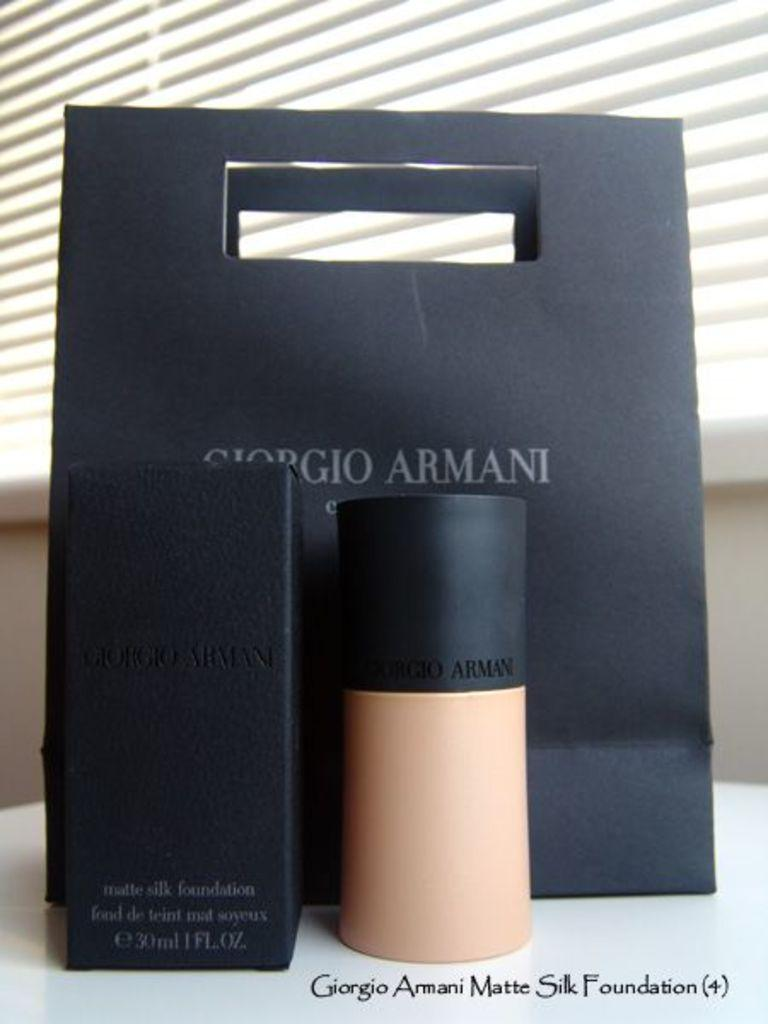Provide a one-sentence caption for the provided image. A black Giorgio Armani bag with a flesh colored container of foundation in front of it as well as the black cardboard container. 